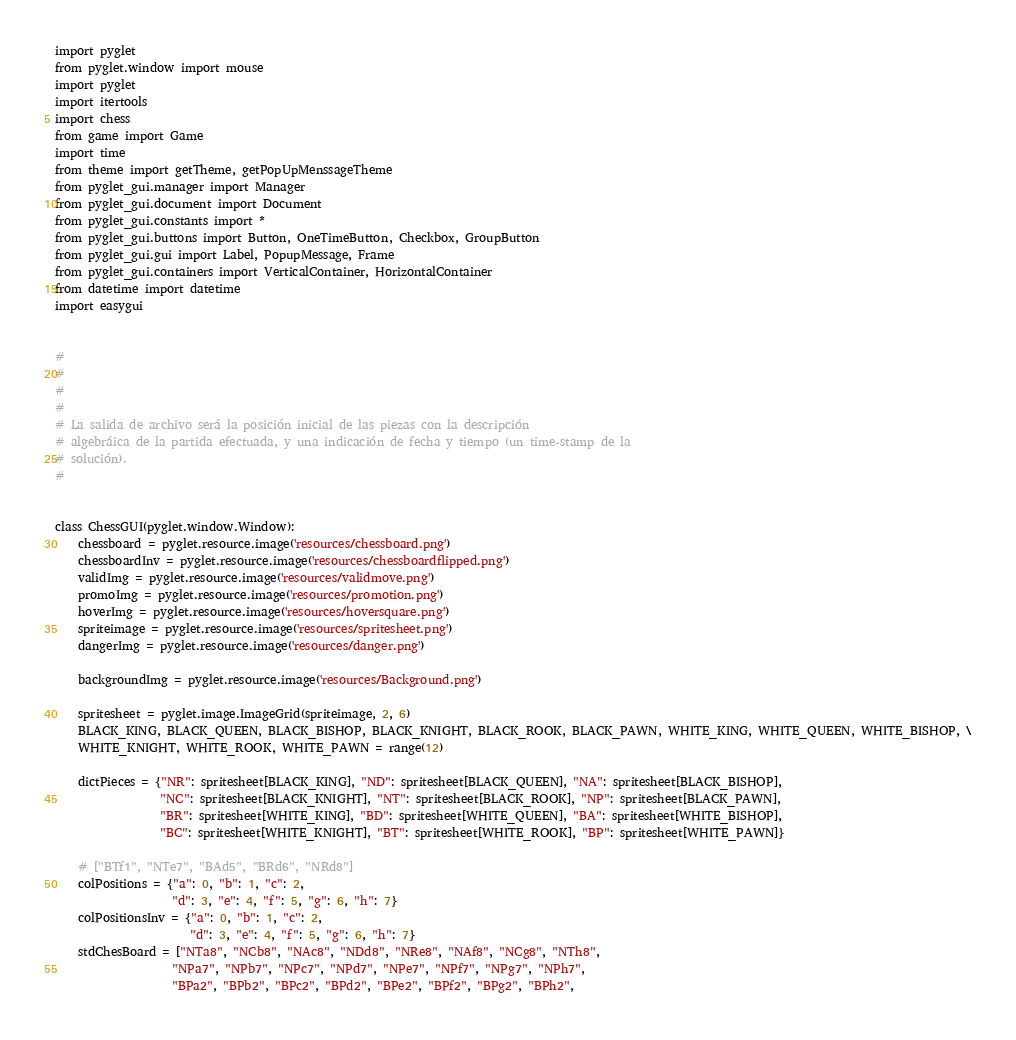<code> <loc_0><loc_0><loc_500><loc_500><_Python_>import pyglet
from pyglet.window import mouse
import pyglet
import itertools
import chess
from game import Game
import time
from theme import getTheme, getPopUpMenssageTheme
from pyglet_gui.manager import Manager
from pyglet_gui.document import Document
from pyglet_gui.constants import *
from pyglet_gui.buttons import Button, OneTimeButton, Checkbox, GroupButton
from pyglet_gui.gui import Label, PopupMessage, Frame
from pyglet_gui.containers import VerticalContainer, HorizontalContainer
from datetime import datetime
import easygui


#
#
#
#
# La salida de archivo será la posición inicial de las piezas con la descripción
# algebráica de la partida efectuada, y una indicación de fecha y tiempo (un time-stamp de la
# solución).
#


class ChessGUI(pyglet.window.Window):
    chessboard = pyglet.resource.image('resources/chessboard.png')
    chessboardInv = pyglet.resource.image('resources/chessboardflipped.png')
    validImg = pyglet.resource.image('resources/validmove.png')
    promoImg = pyglet.resource.image('resources/promotion.png')
    hoverImg = pyglet.resource.image('resources/hoversquare.png')
    spriteimage = pyglet.resource.image('resources/spritesheet.png')
    dangerImg = pyglet.resource.image('resources/danger.png')

    backgroundImg = pyglet.resource.image('resources/Background.png')

    spritesheet = pyglet.image.ImageGrid(spriteimage, 2, 6)
    BLACK_KING, BLACK_QUEEN, BLACK_BISHOP, BLACK_KNIGHT, BLACK_ROOK, BLACK_PAWN, WHITE_KING, WHITE_QUEEN, WHITE_BISHOP, \
    WHITE_KNIGHT, WHITE_ROOK, WHITE_PAWN = range(12)

    dictPieces = {"NR": spritesheet[BLACK_KING], "ND": spritesheet[BLACK_QUEEN], "NA": spritesheet[BLACK_BISHOP],
                  "NC": spritesheet[BLACK_KNIGHT], "NT": spritesheet[BLACK_ROOK], "NP": spritesheet[BLACK_PAWN],
                  "BR": spritesheet[WHITE_KING], "BD": spritesheet[WHITE_QUEEN], "BA": spritesheet[WHITE_BISHOP],
                  "BC": spritesheet[WHITE_KNIGHT], "BT": spritesheet[WHITE_ROOK], "BP": spritesheet[WHITE_PAWN]}

    # ["BTf1", "NTe7", "BAd5", "BRd6", "NRd8"]
    colPositions = {"a": 0, "b": 1, "c": 2,
                    "d": 3, "e": 4, "f": 5, "g": 6, "h": 7}
    colPositionsInv = {"a": 0, "b": 1, "c": 2,
                       "d": 3, "e": 4, "f": 5, "g": 6, "h": 7}
    stdChesBoard = ["NTa8", "NCb8", "NAc8", "NDd8", "NRe8", "NAf8", "NCg8", "NTh8",
                    "NPa7", "NPb7", "NPc7", "NPd7", "NPe7", "NPf7", "NPg7", "NPh7",
                    "BPa2", "BPb2", "BPc2", "BPd2", "BPe2", "BPf2", "BPg2", "BPh2",</code> 